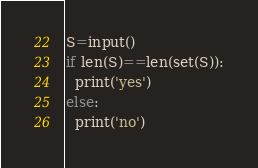Convert code to text. <code><loc_0><loc_0><loc_500><loc_500><_Python_>S=input()
if len(S)==len(set(S)):
  print('yes')
else:
  print('no')</code> 